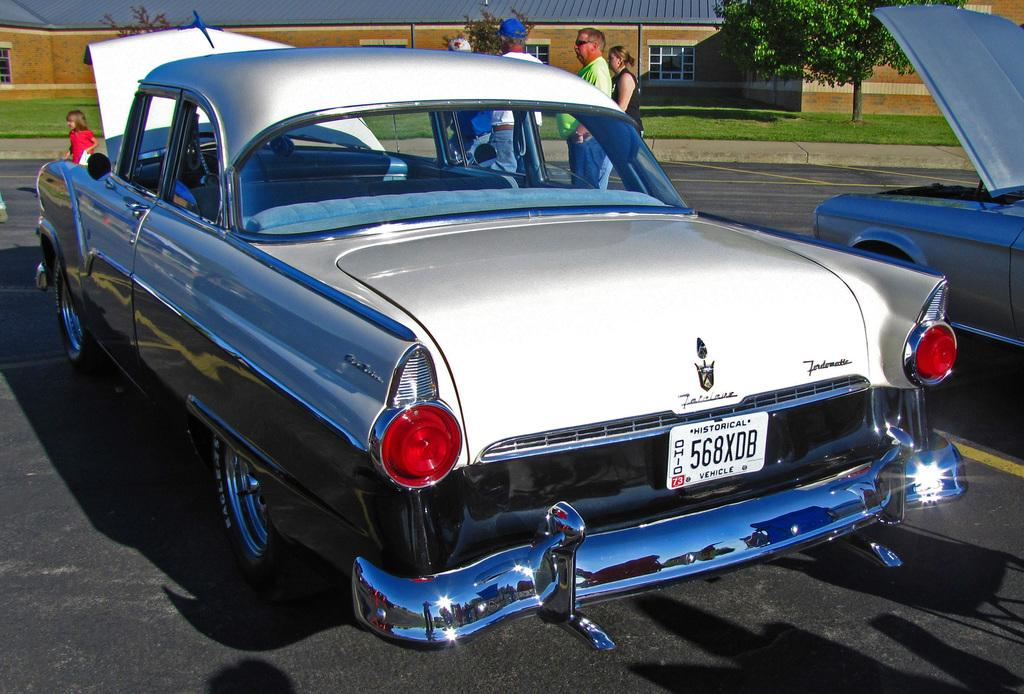What can be seen in the front portion of the image? There are vehicles and people in the front portion of the image. What is located in the background portion of the image? There is a house, trees, and grass in the background portion of the image. What type of record can be seen being played in the image? There is no record present in the image. What event is taking place in the image? The image does not depict a specific event; it shows vehicles, people, a house, trees, and grass. 